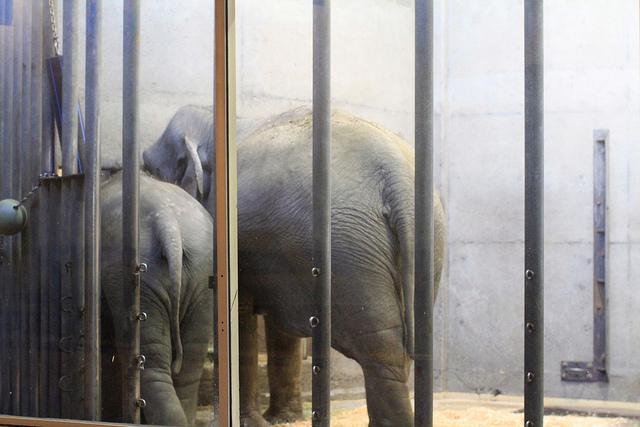Are these animals in the wilderness?
Concise answer only. No. What sort of animal is in the pen?
Answer briefly. Elephant. What part of the animal faces the camera?
Short answer required. Butt. Do these animals have tails?
Short answer required. Yes. 